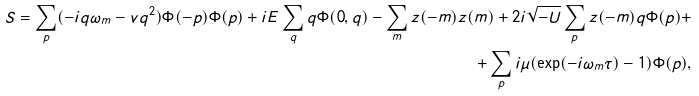<formula> <loc_0><loc_0><loc_500><loc_500>S = \sum _ { p } ( - i q \omega _ { m } - v q ^ { 2 } ) \Phi ( - p ) \Phi ( p ) + i E \sum _ { q } q \Phi ( 0 , q ) - \sum _ { m } z ( - m ) z ( m ) + 2 i \sqrt { - U } \sum _ { p } z ( - m ) q \Phi ( p ) + \\ + \sum _ { p } i \mu ( \exp ( - i \omega _ { m } \tau ) - 1 ) \Phi ( p ) ,</formula> 